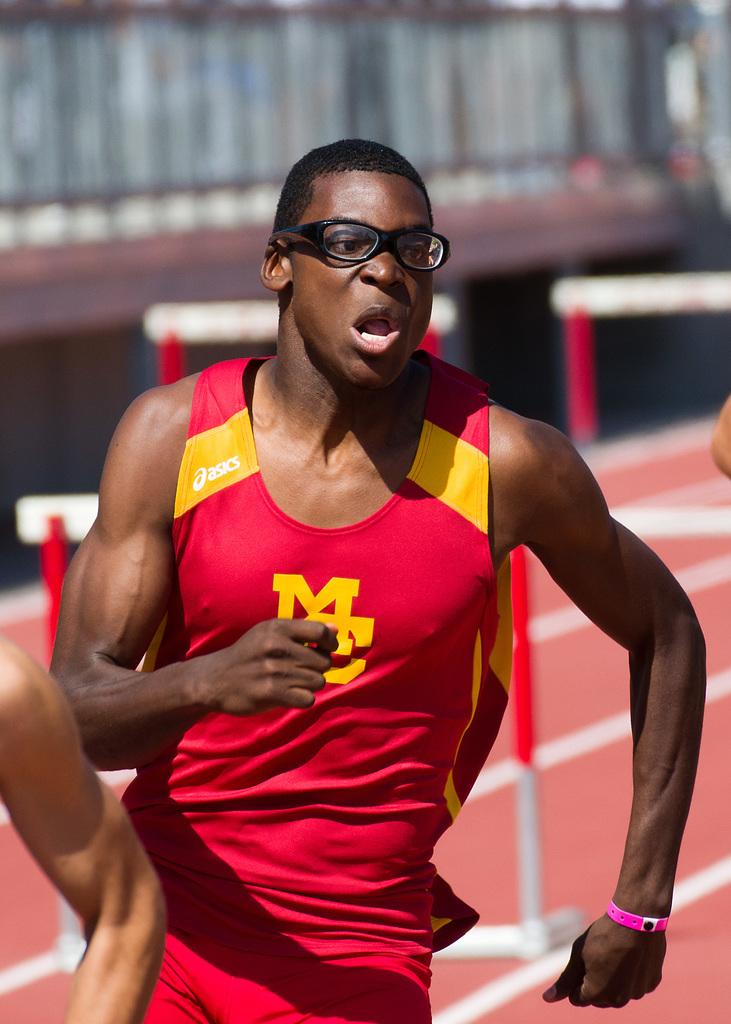What are the initials of the runner's school?
Your answer should be very brief. Mc. What brand is the runner's jersey?
Provide a short and direct response. Asics. 